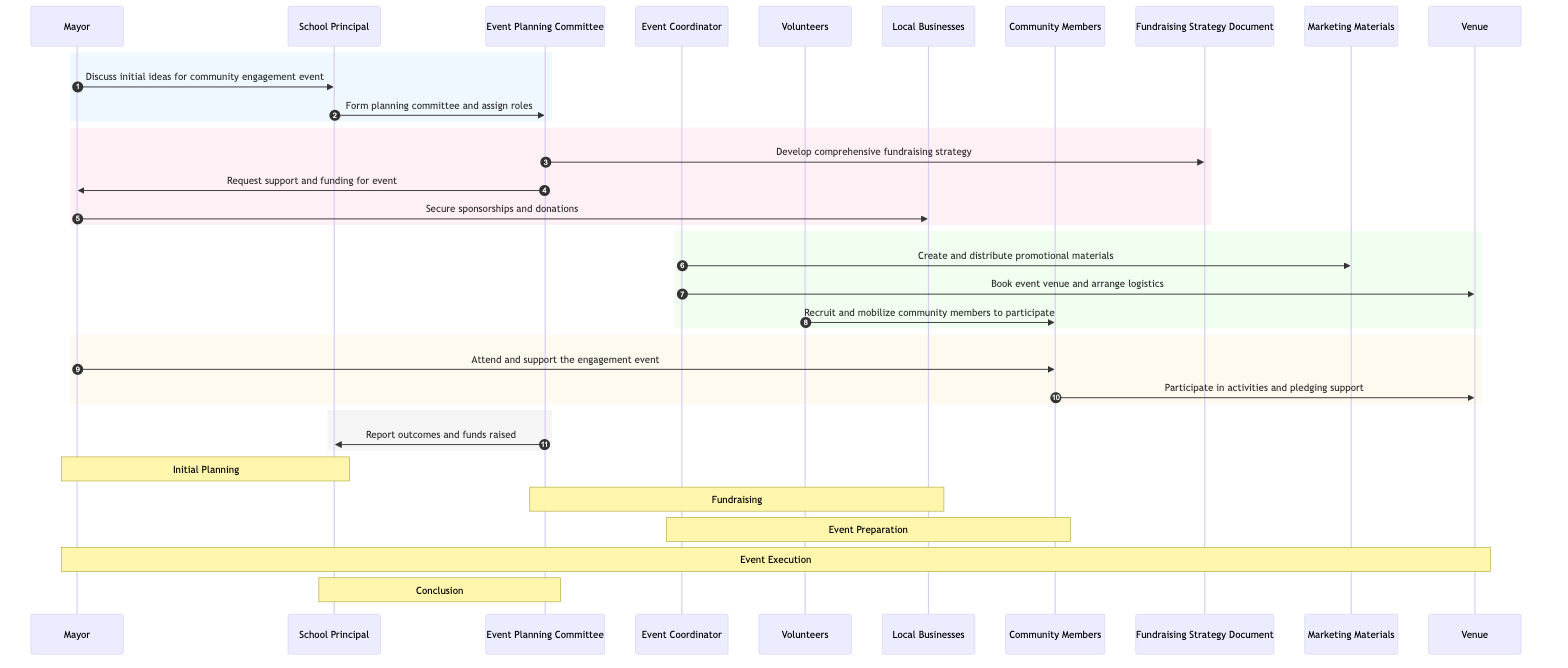What is the first interaction that occurs in the sequence diagram? The first interaction is between the Mayor and the School Principal, where they discuss initial ideas for a community engagement event. This interaction is listed first in the sequence.
Answer: Discuss initial ideas for community engagement event How many actors are involved in the sequence diagram? The sequence diagram includes six distinct actors: Mayor, School Principal, Community Members, Event Coordinator, Volunteers, and Local Businesses. By counting these entities, we can determine the total number of actors.
Answer: 6 Who is responsible for securing sponsorships and donations? In the sequence diagram, the Mayor is depicted as the one responsible for securing sponsorships and donations from local businesses, as shown in the interaction where he communicates with them.
Answer: Mayor What document is developed by the Event Planning Committee? The Event Planning Committee develops a comprehensive fundraising strategy document, as indicated in their interaction with this document.
Answer: Fundraising Strategy Document Which actor interacts with the volunteers? The Volunteers interact with the Community Members to recruit and mobilize them for participation in the event, highlighting the connection and role of Volunteers in the process.
Answer: Community Members What is the outcome reported at the end of the sequence? At the end of the sequence, the Event Planning Committee reports the outcomes and funds raised to the School Principal, indicating the conclusion of the fundraising efforts.
Answer: Outcomes and funds raised How many messages does the Event Planning Committee send? The Event Planning Committee sends three messages: one to the Fundraising Strategy Document, one to the Mayor, and one to the School Principal. Counting these interactions gives us the total messages sent by this actor.
Answer: 3 What stage involves local businesses? The stage that involves local businesses is the Fundraising stage, where the Mayor interacts with them to secure sponsorships and donations for the event. This stage highlights the participation of businesses in the planning process.
Answer: Fundraising What action does the Event Coordinator take regarding marketing? The Event Coordinator creates and distributes promotional materials, as indicated in the interaction where this action is outlined in the diagram. This describes the marketing efforts made for the event.
Answer: Create and distribute promotional materials 